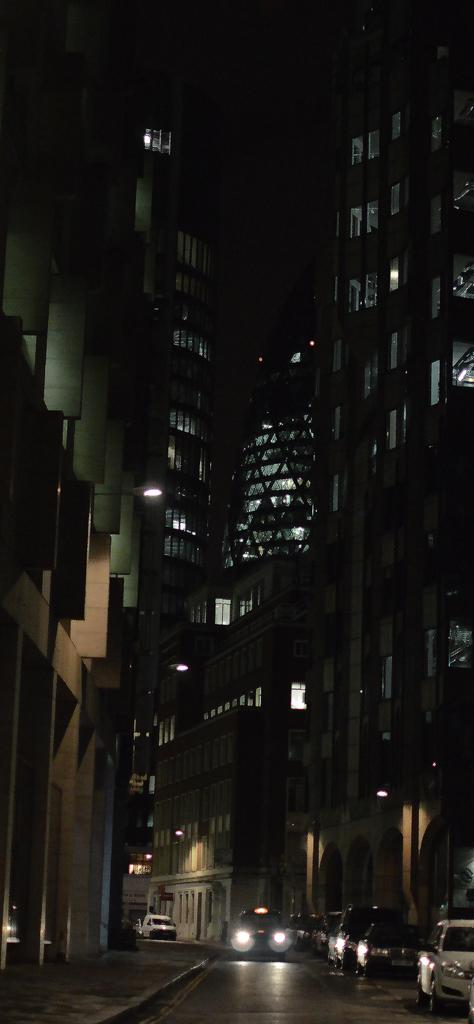What is happening on the road in the image? There are vehicles on the road in the image. What type of path is present for pedestrians in the image? There is a footpath in the image. What can be seen on the buildings in the image? There are buildings with windows in the image. What is illuminating the scene in the image? There are lights visible in the image. How would you describe the overall lighting in the image? The background of the image is dark. Where is the sign for the ice cream shop in the image? There is no sign for an ice cream shop present in the image. Can you see any ice on the sidewalk in the image? There is no ice visible on the sidewalk in the image. 